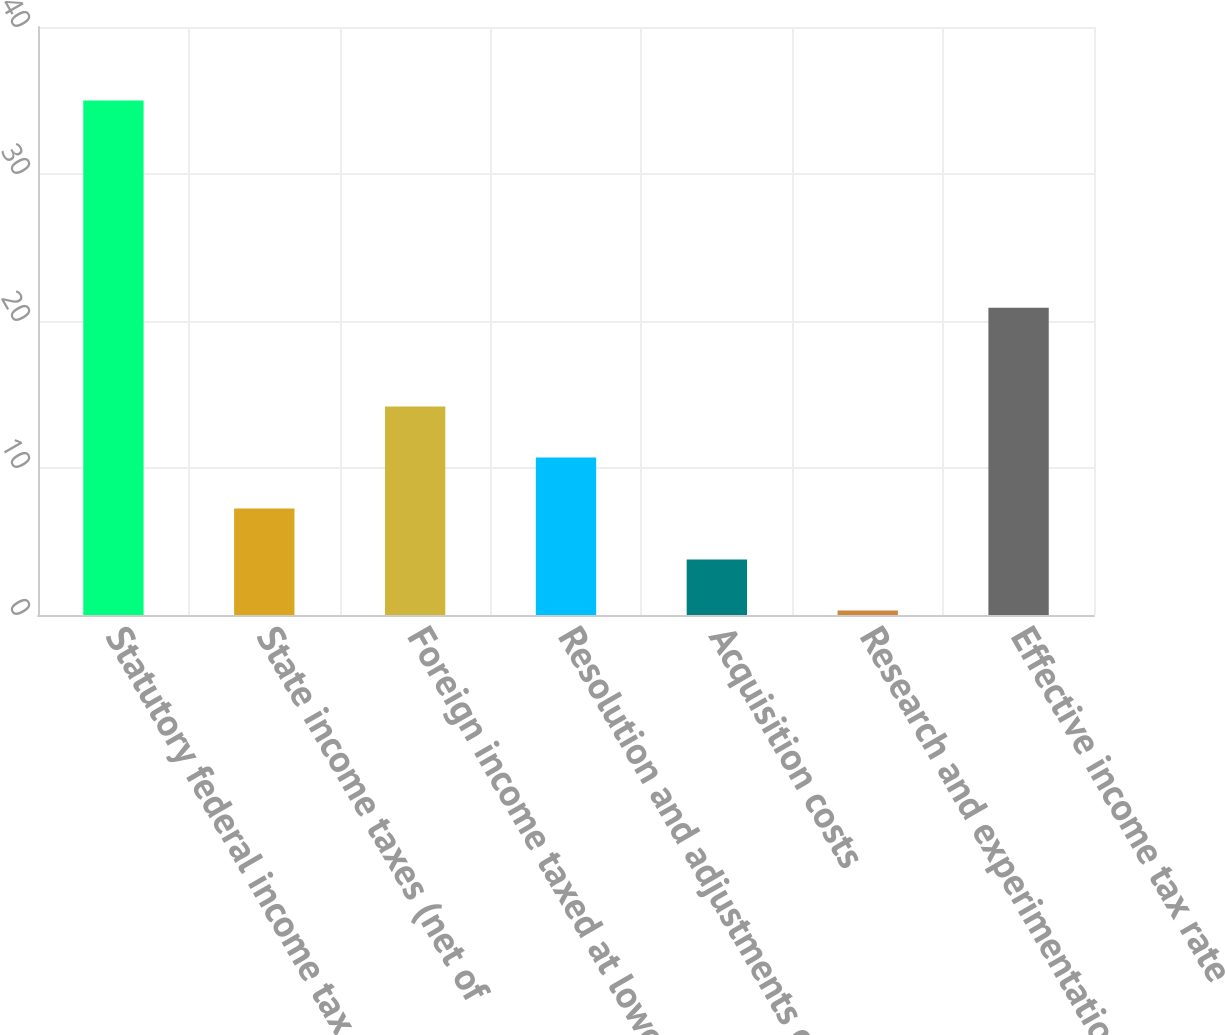Convert chart. <chart><loc_0><loc_0><loc_500><loc_500><bar_chart><fcel>Statutory federal income tax<fcel>State income taxes (net of<fcel>Foreign income taxed at lower<fcel>Resolution and adjustments of<fcel>Acquisition costs<fcel>Research and experimentation<fcel>Effective income tax rate<nl><fcel>35<fcel>7.24<fcel>14.18<fcel>10.71<fcel>3.77<fcel>0.3<fcel>20.9<nl></chart> 